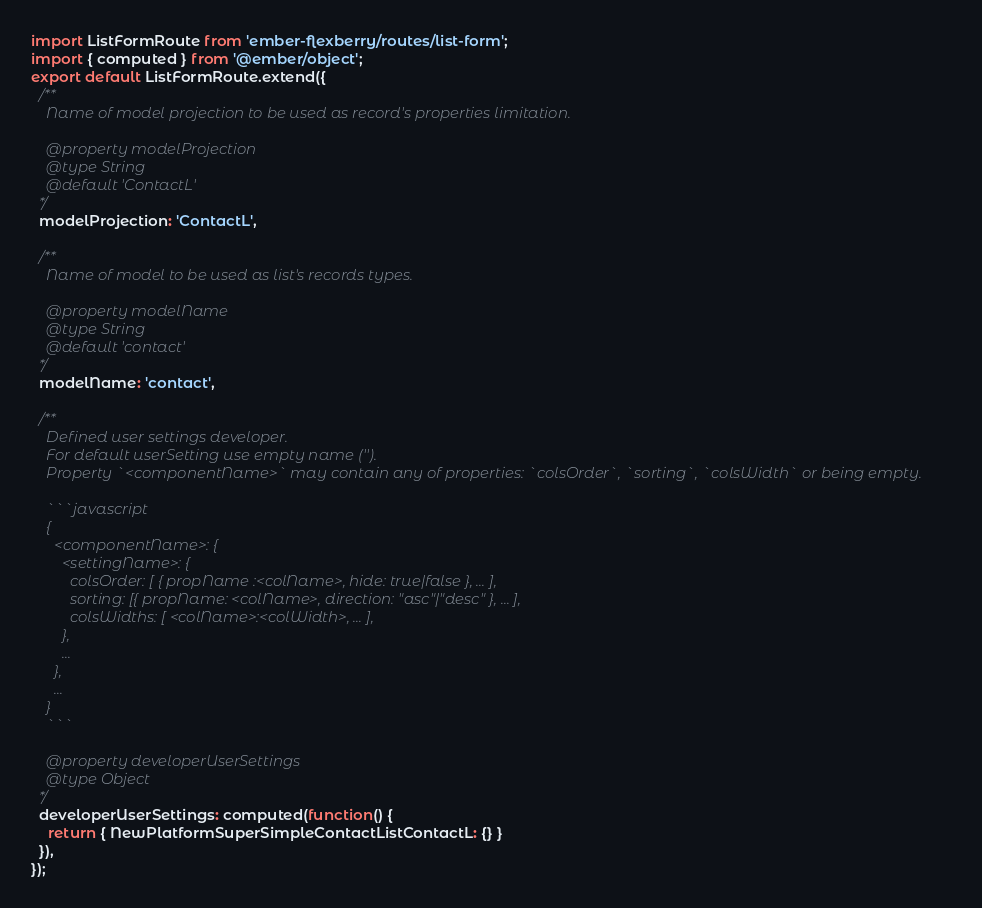Convert code to text. <code><loc_0><loc_0><loc_500><loc_500><_JavaScript_>import ListFormRoute from 'ember-flexberry/routes/list-form';
import { computed } from '@ember/object';
export default ListFormRoute.extend({
  /**
    Name of model projection to be used as record's properties limitation.

    @property modelProjection
    @type String
    @default 'ContactL'
  */
  modelProjection: 'ContactL',

  /**
    Name of model to be used as list's records types.

    @property modelName
    @type String
    @default 'contact'
  */
  modelName: 'contact',

  /**
    Defined user settings developer.
    For default userSetting use empty name ('').
    Property `<componentName>` may contain any of properties: `colsOrder`, `sorting`, `colsWidth` or being empty.

    ```javascript
    {
      <componentName>: {
        <settingName>: {
          colsOrder: [ { propName :<colName>, hide: true|false }, ... ],
          sorting: [{ propName: <colName>, direction: "asc"|"desc" }, ... ],
          colsWidths: [ <colName>:<colWidth>, ... ],
        },
        ...
      },
      ...
    }
    ```

    @property developerUserSettings
    @type Object
  */
  developerUserSettings: computed(function() {
    return { NewPlatformSuperSimpleContactListContactL: {} }
  }),
});
</code> 